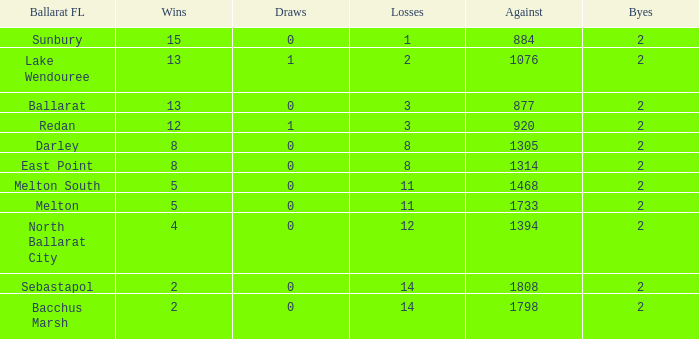In a ballarat fl of melton south, how many losses are there with an opposition larger than 1468? 0.0. 